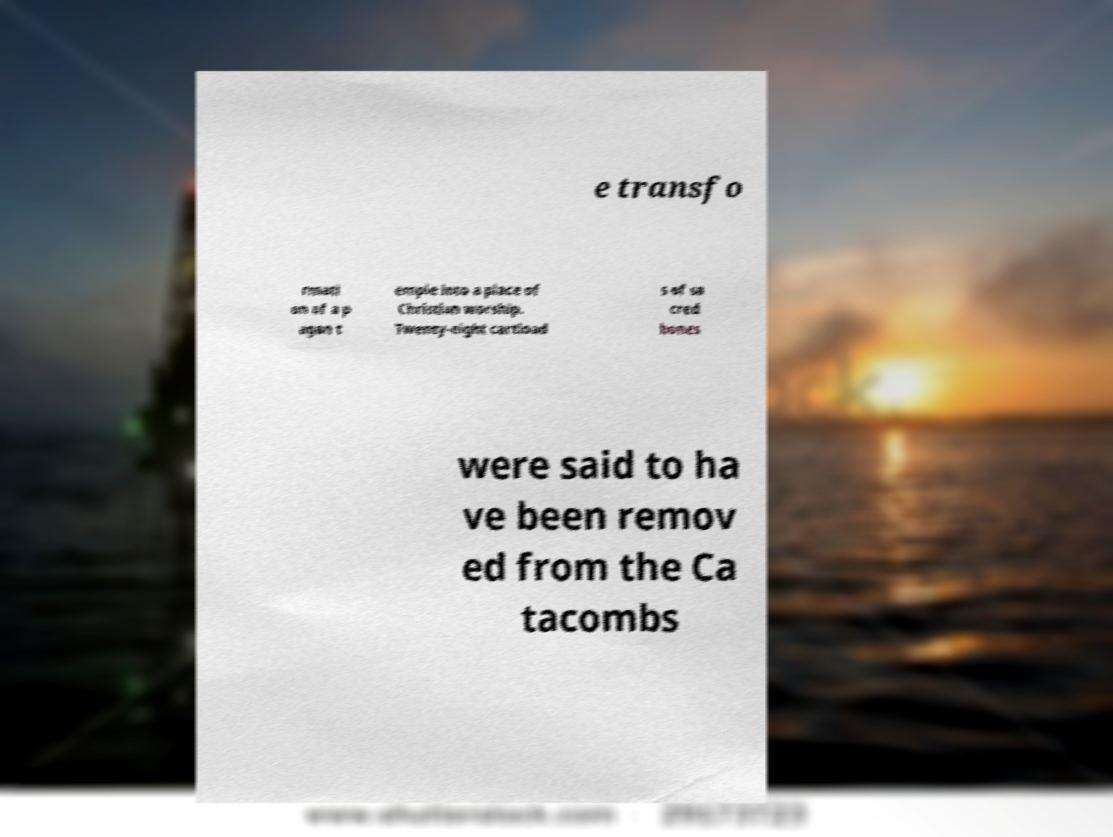Please identify and transcribe the text found in this image. e transfo rmati on of a p agan t emple into a place of Christian worship. Twenty-eight cartload s of sa cred bones were said to ha ve been remov ed from the Ca tacombs 